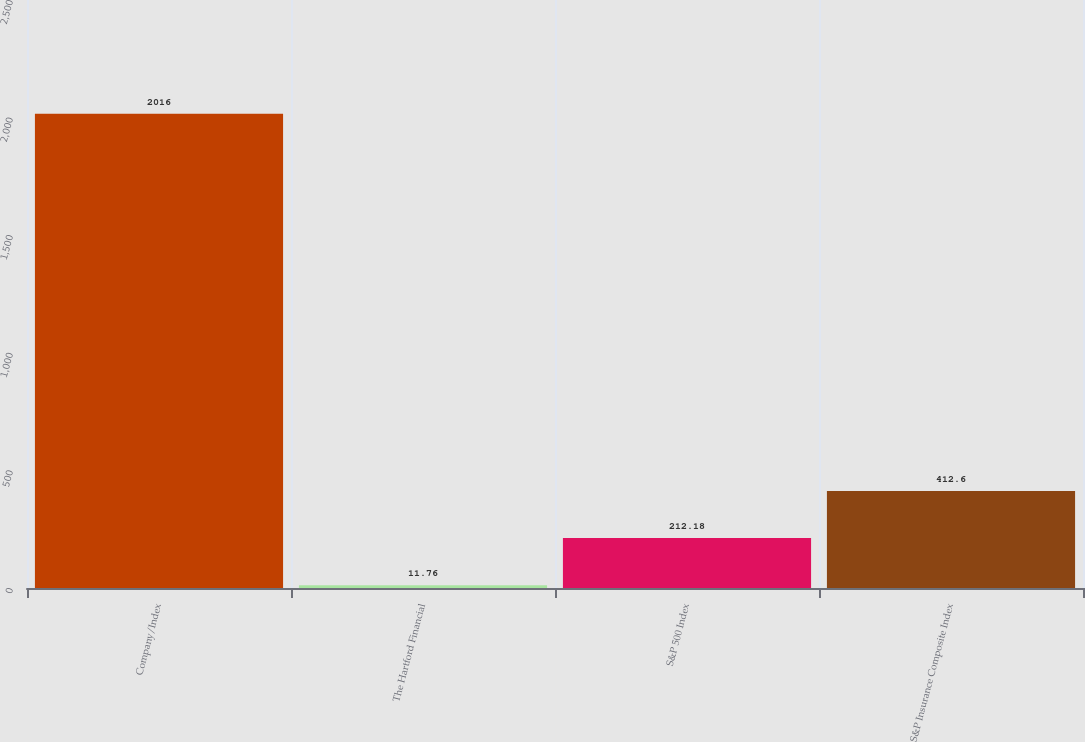<chart> <loc_0><loc_0><loc_500><loc_500><bar_chart><fcel>Company/Index<fcel>The Hartford Financial<fcel>S&P 500 Index<fcel>S&P Insurance Composite Index<nl><fcel>2016<fcel>11.76<fcel>212.18<fcel>412.6<nl></chart> 